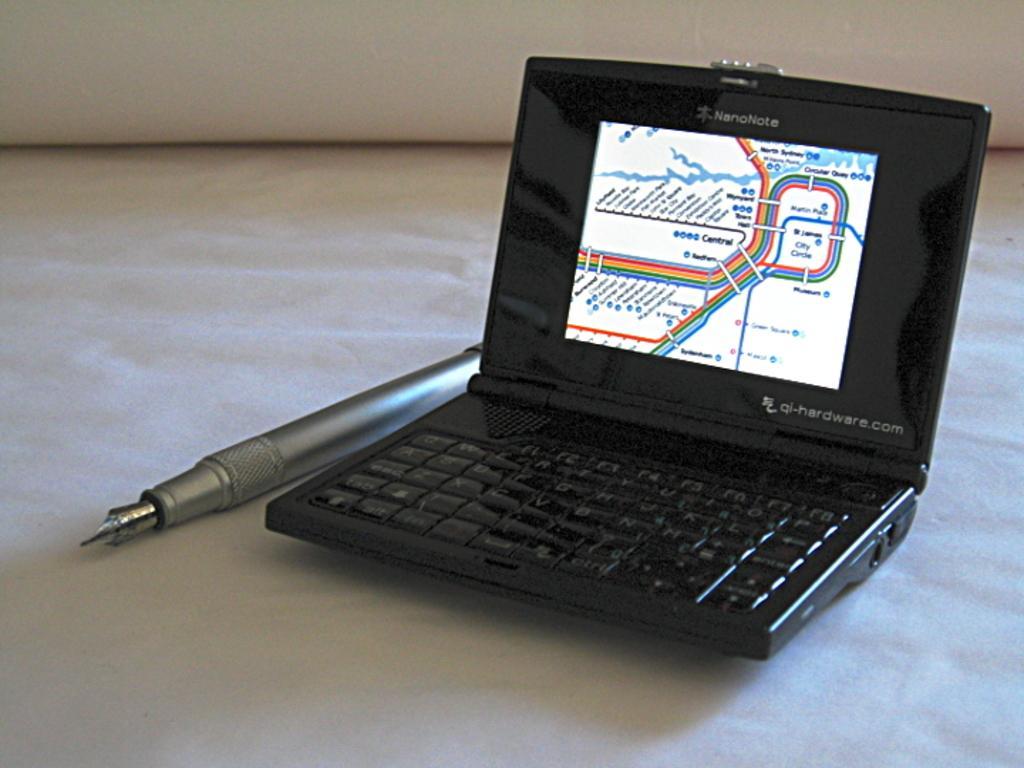Please provide a concise description of this image. In this image, there is small black color laptop and there is a ash color pen kept on a white color object. 